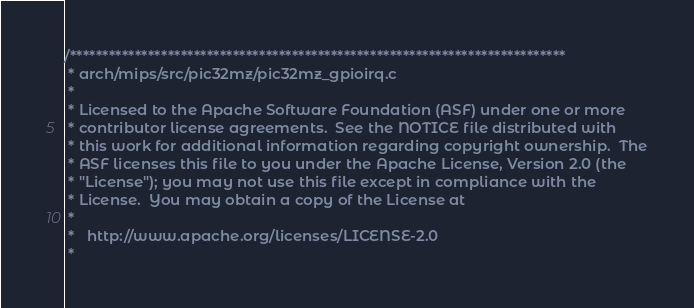Convert code to text. <code><loc_0><loc_0><loc_500><loc_500><_C_>/****************************************************************************
 * arch/mips/src/pic32mz/pic32mz_gpioirq.c
 *
 * Licensed to the Apache Software Foundation (ASF) under one or more
 * contributor license agreements.  See the NOTICE file distributed with
 * this work for additional information regarding copyright ownership.  The
 * ASF licenses this file to you under the Apache License, Version 2.0 (the
 * "License"); you may not use this file except in compliance with the
 * License.  You may obtain a copy of the License at
 *
 *   http://www.apache.org/licenses/LICENSE-2.0
 *</code> 